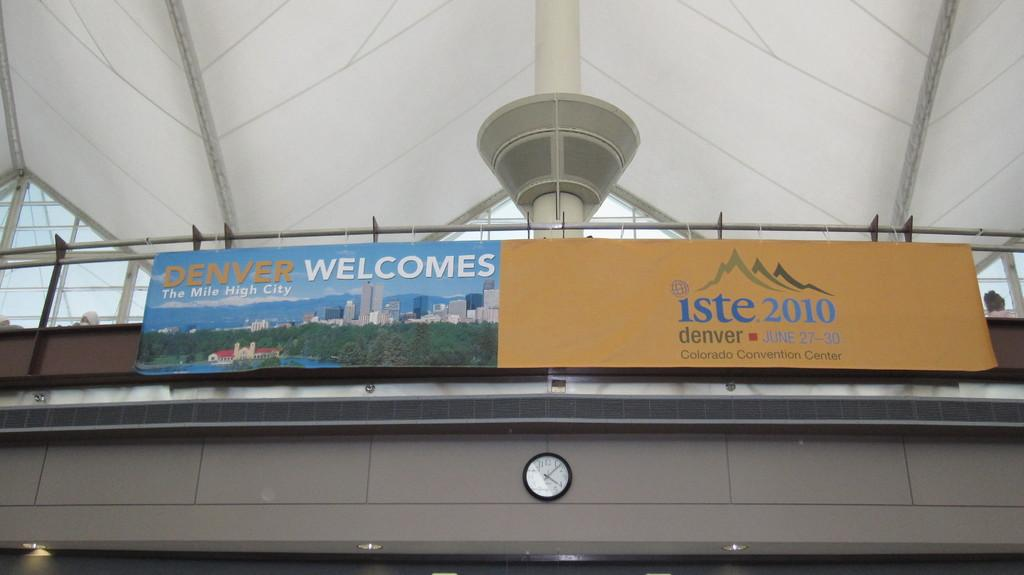<image>
Render a clear and concise summary of the photo. sme signs saying Denver Welcomes and iste 2010. 